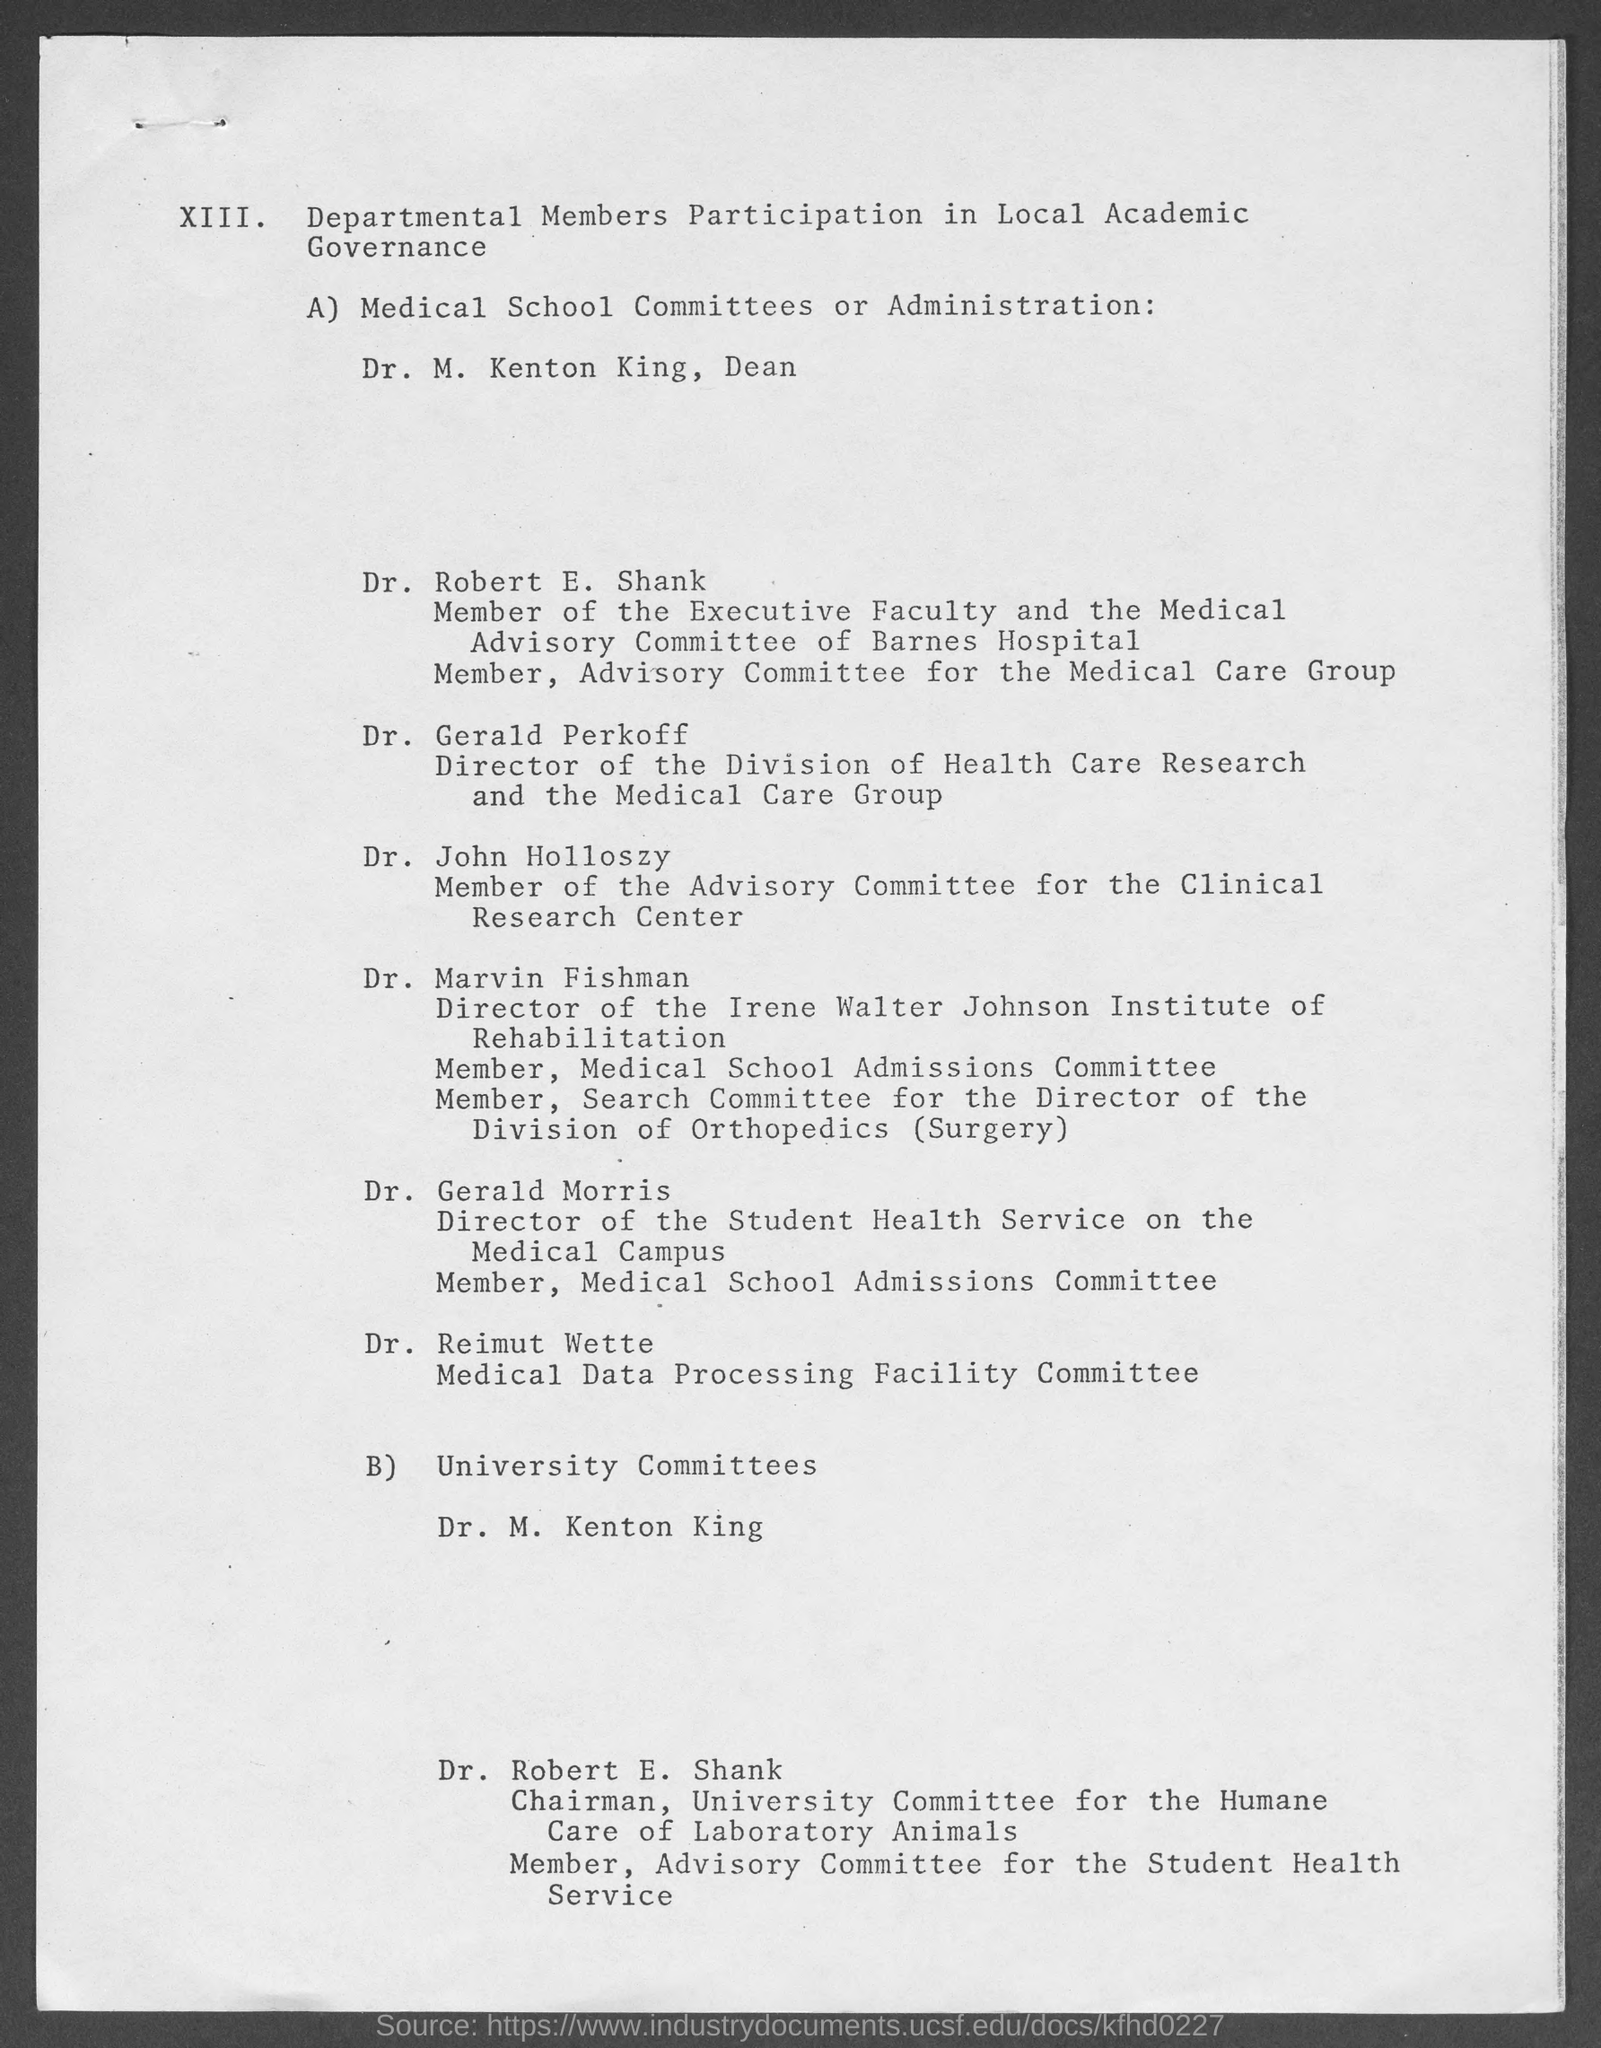What is the position of dr. m. kenton king ?
Your response must be concise. Dean. Who is the director of the division of health care research and the medical care group?
Ensure brevity in your answer.  Dr. Gerald Perkoff. Who is the member of the advisory committee for the clinical research center ?
Keep it short and to the point. Dr. John Holloszy. Who is the director of the student health service on the medical campus ?
Your answer should be compact. Dr. Gerald Morris. 